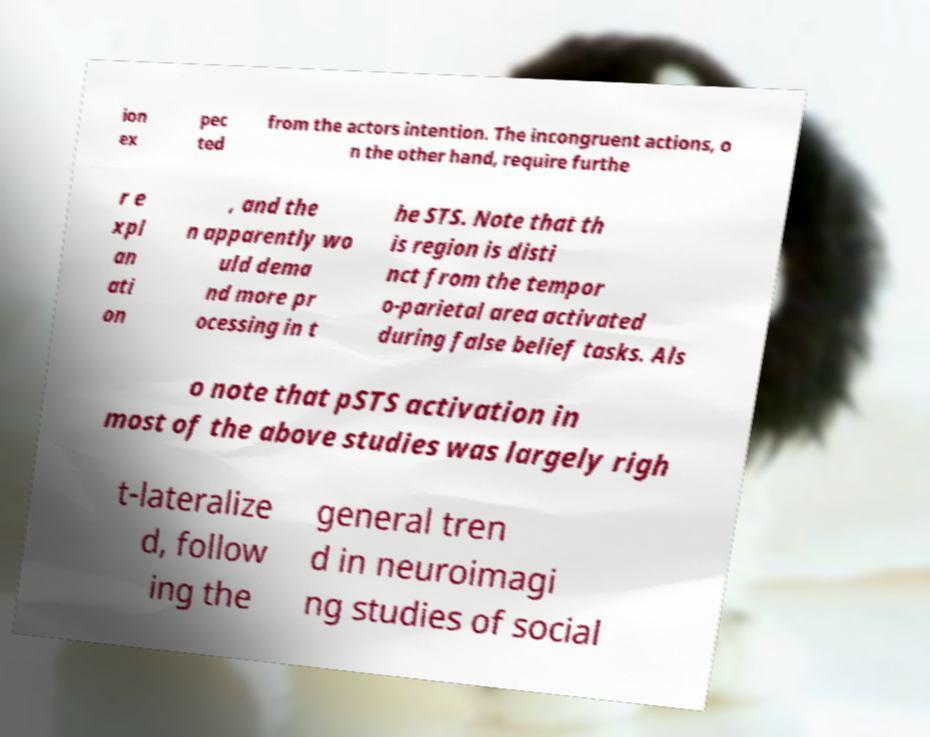Please read and relay the text visible in this image. What does it say? ion ex pec ted from the actors intention. The incongruent actions, o n the other hand, require furthe r e xpl an ati on , and the n apparently wo uld dema nd more pr ocessing in t he STS. Note that th is region is disti nct from the tempor o-parietal area activated during false belief tasks. Als o note that pSTS activation in most of the above studies was largely righ t-lateralize d, follow ing the general tren d in neuroimagi ng studies of social 